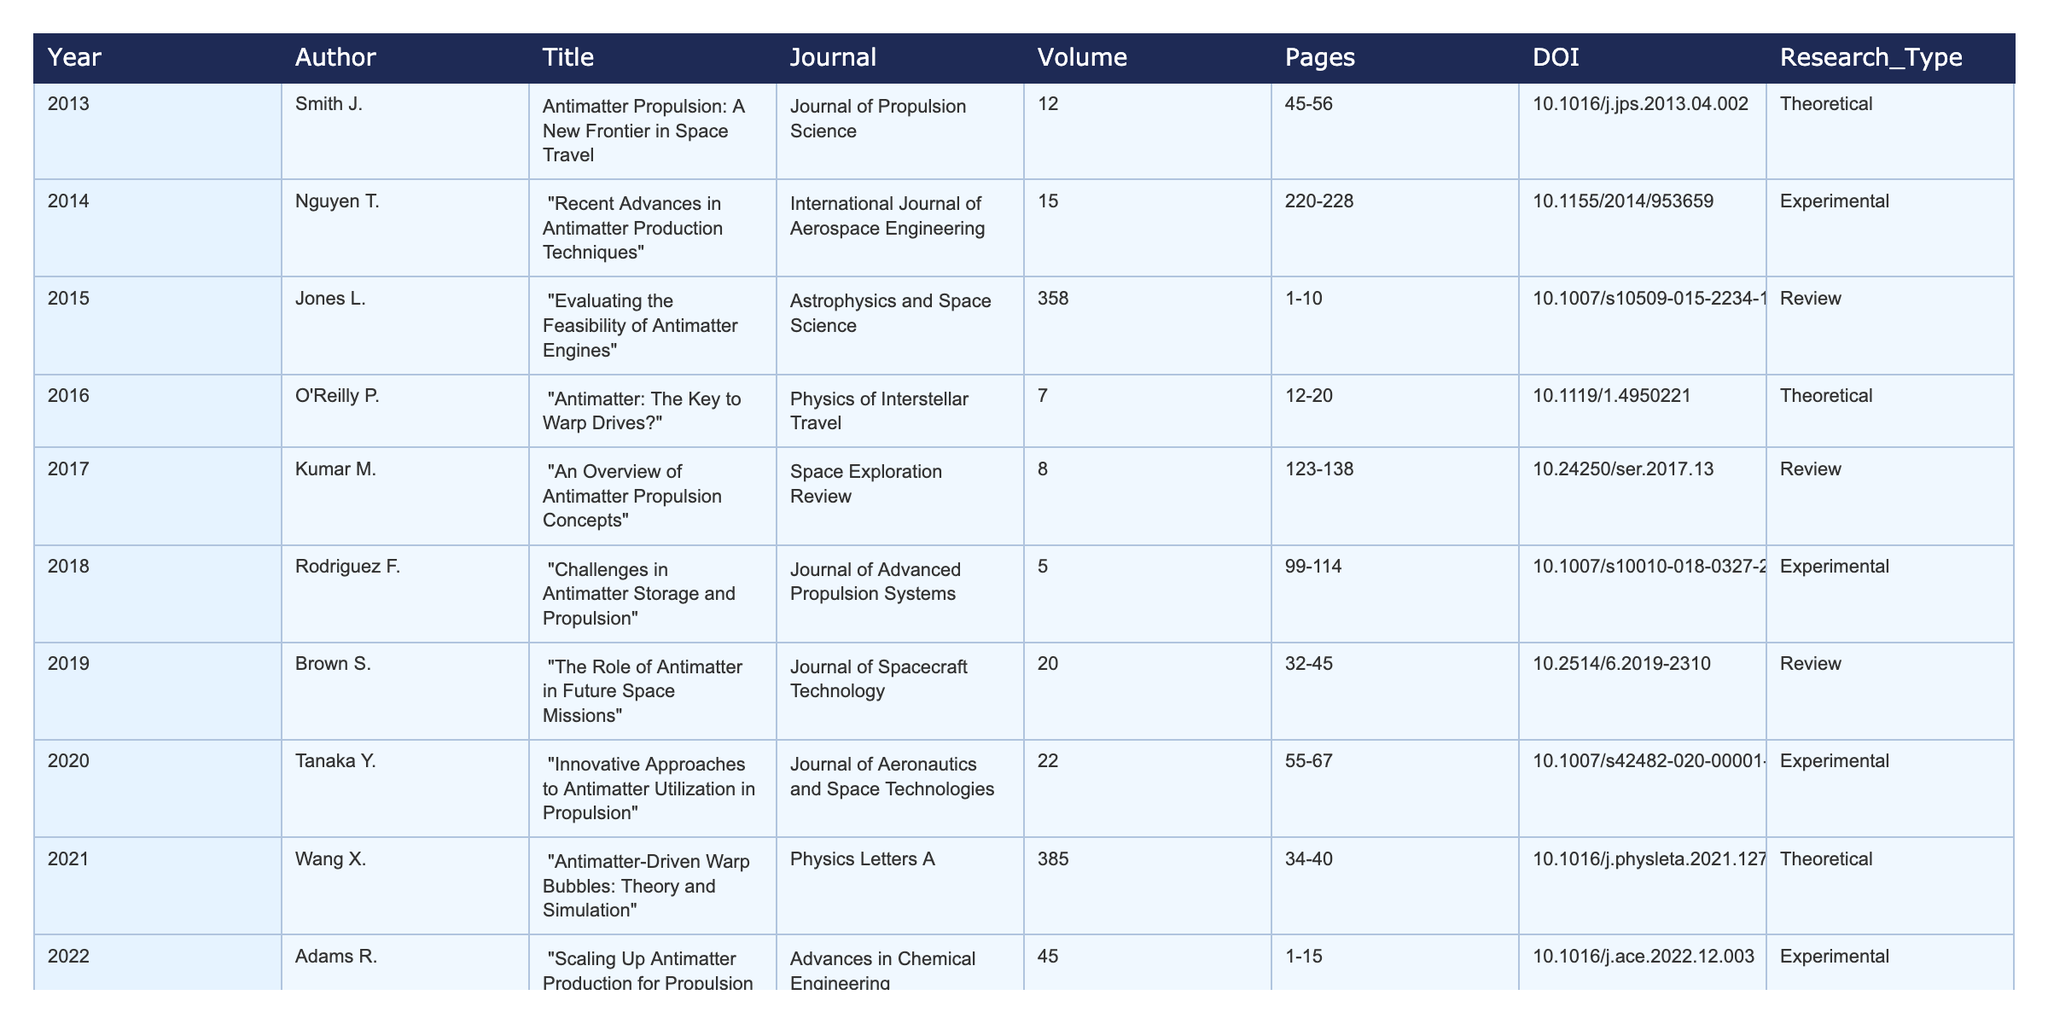What is the title of the publication from 2019? The publication from 2019 is titled "The Role of Antimatter in Future Space Missions."
Answer: The Role of Antimatter in Future Space Missions How many experimental research publications are listed in the table? The table contains three experimental research publications from 2014, 2018, and 2020.
Answer: Three What is the average volume number of theoretical publications? The theoretical publications are from 2013, 2016, and 2021, with volume numbers 12, 7, and 385, respectively. Their sum is 404, and the average is 404/3 = 134.67.
Answer: 134.67 Which journal published the most recent review on antimatter propulsion? The most recent review is titled "Potential Interstellar Missions Using Antimatter Engines," which was published in "Journal of Interstellar Studies" in 2023.
Answer: Journal of Interstellar Studies What is the DOI of the publication titled "Challenges in Antimatter Storage and Propulsion"? The DOI for "Challenges in Antimatter Storage and Propulsion" is 10.1007/s10010-018-0327-2.
Answer: 10.1007/s10010-018-0327-2 Are there any publications from 2021 related to theoretical research? Yes, the 2021 publication "Antimatter-Driven Warp Bubbles: Theory and Simulation" is related to theoretical research.
Answer: Yes Identify the earliest publication focused on review-type research. The earliest review-type publication is from 2015 titled "Evaluating the Feasibility of Antimatter Engines."
Answer: Evaluating the Feasibility of Antimatter Engines How many different authors contributed to experimental research articles? The authors for experimental research articles are Nguyen T., Rodriguez F., Tanaka Y., and Adams R., totaling four different authors.
Answer: Four What percentage of the total publications listed are classified as reviews? There are three review publications out of ten total publications, so the percentage is (3/10)*100 = 30%.
Answer: 30% Which author has published a theoretical research article on warp drives? The author Wang X. published the theoretical research article titled "Antimatter-Driven Warp Bubbles: Theory and Simulation."
Answer: Wang X 